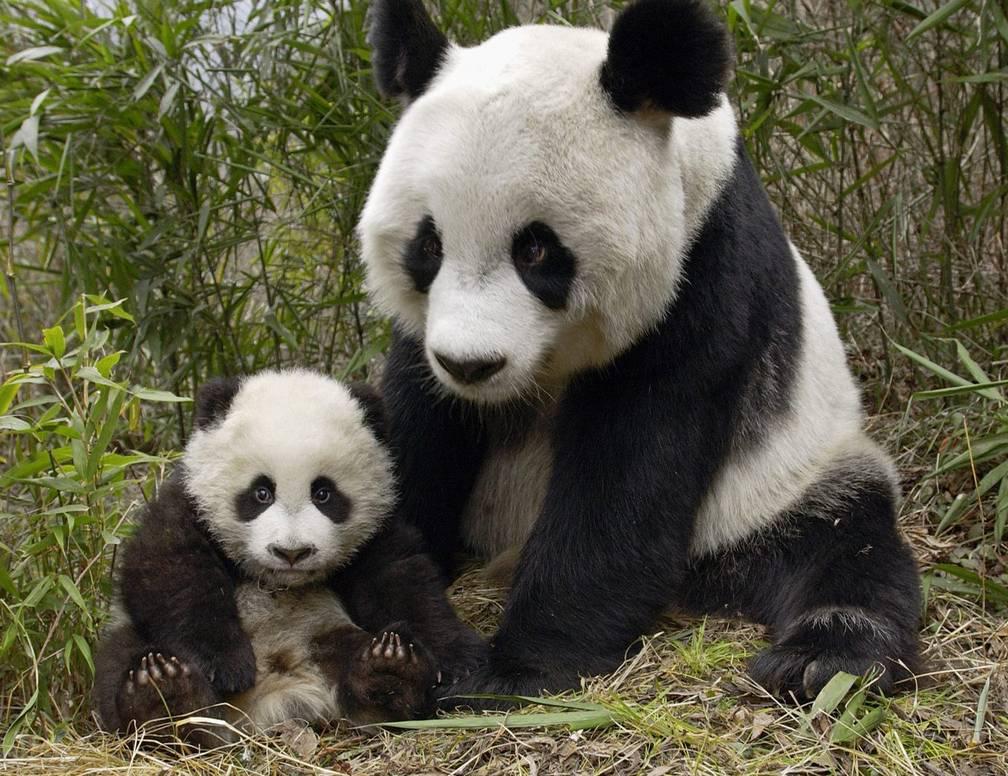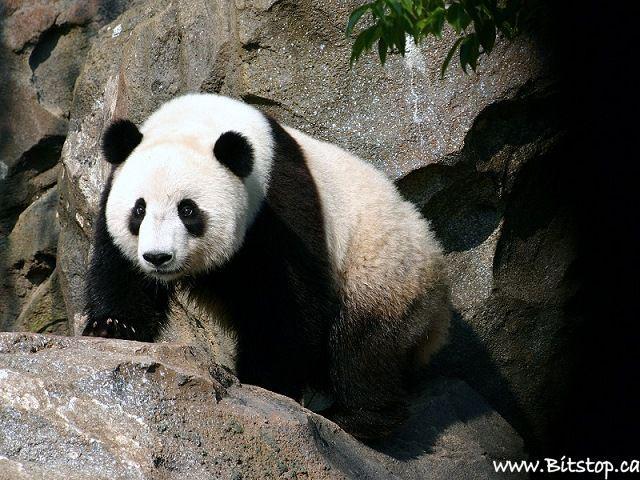The first image is the image on the left, the second image is the image on the right. For the images shown, is this caption "There are three pandas" true? Answer yes or no. Yes. The first image is the image on the left, the second image is the image on the right. Given the left and right images, does the statement "there are at most 2 pandas in the image pair" hold true? Answer yes or no. No. 